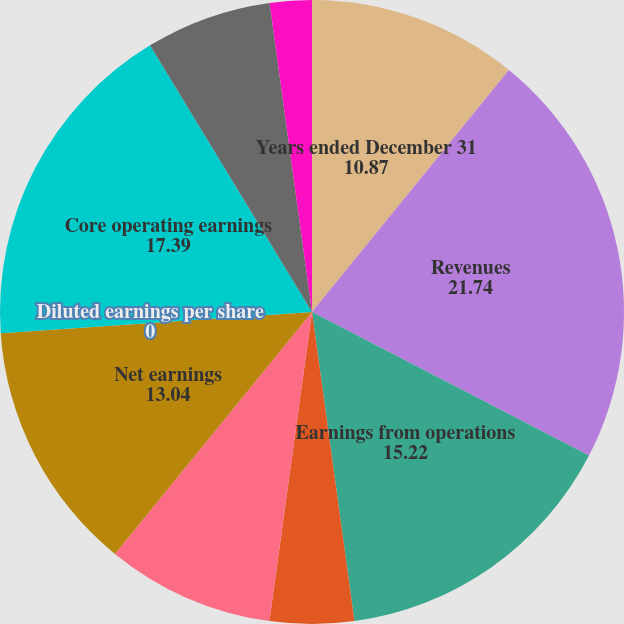Convert chart to OTSL. <chart><loc_0><loc_0><loc_500><loc_500><pie_chart><fcel>Years ended December 31<fcel>Revenues<fcel>Earnings from operations<fcel>Operating margins<fcel>Effective income tax rate<fcel>Net earnings<fcel>Diluted earnings per share<fcel>Core operating earnings<fcel>Core operating margin<fcel>Core earnings per share<nl><fcel>10.87%<fcel>21.74%<fcel>15.22%<fcel>4.35%<fcel>8.7%<fcel>13.04%<fcel>0.0%<fcel>17.39%<fcel>6.52%<fcel>2.17%<nl></chart> 